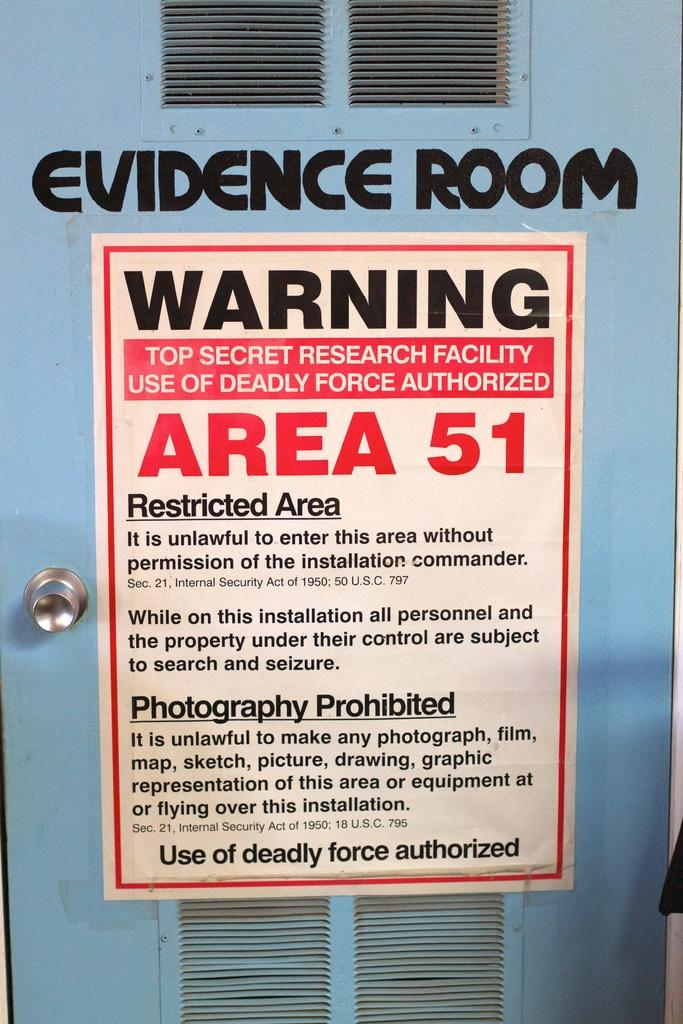<image>
Summarize the visual content of the image. A Warning sign at Area 51 which is an Evidence Room 